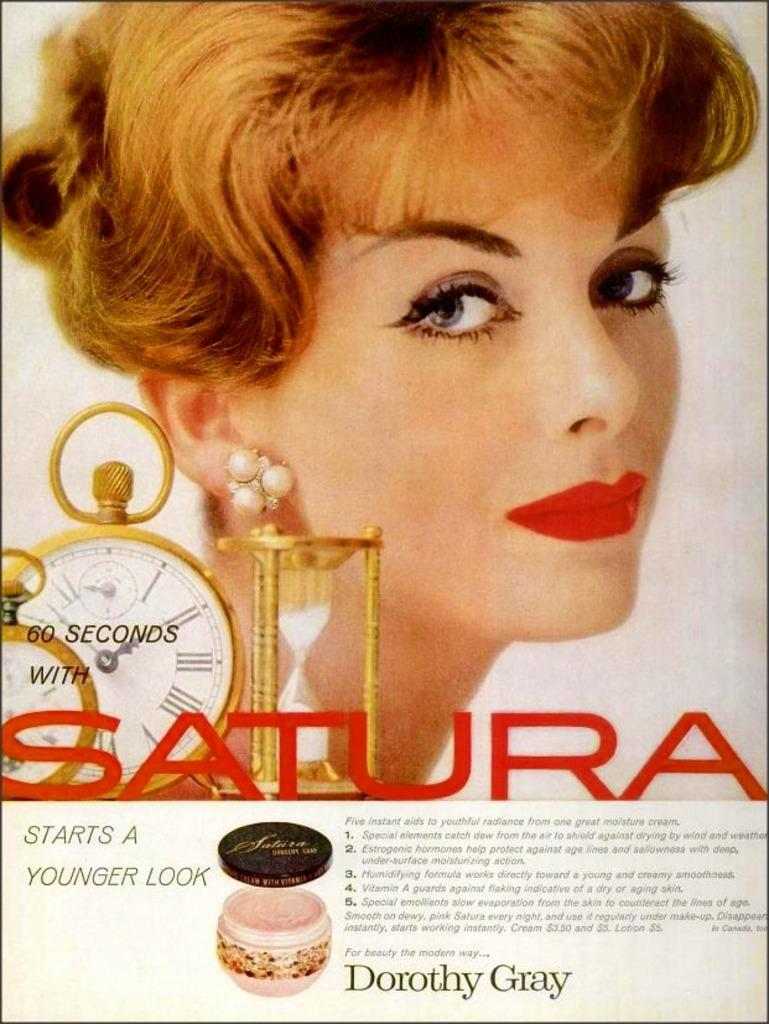<image>
Relay a brief, clear account of the picture shown. A page from a magazine that is advertising Satura 